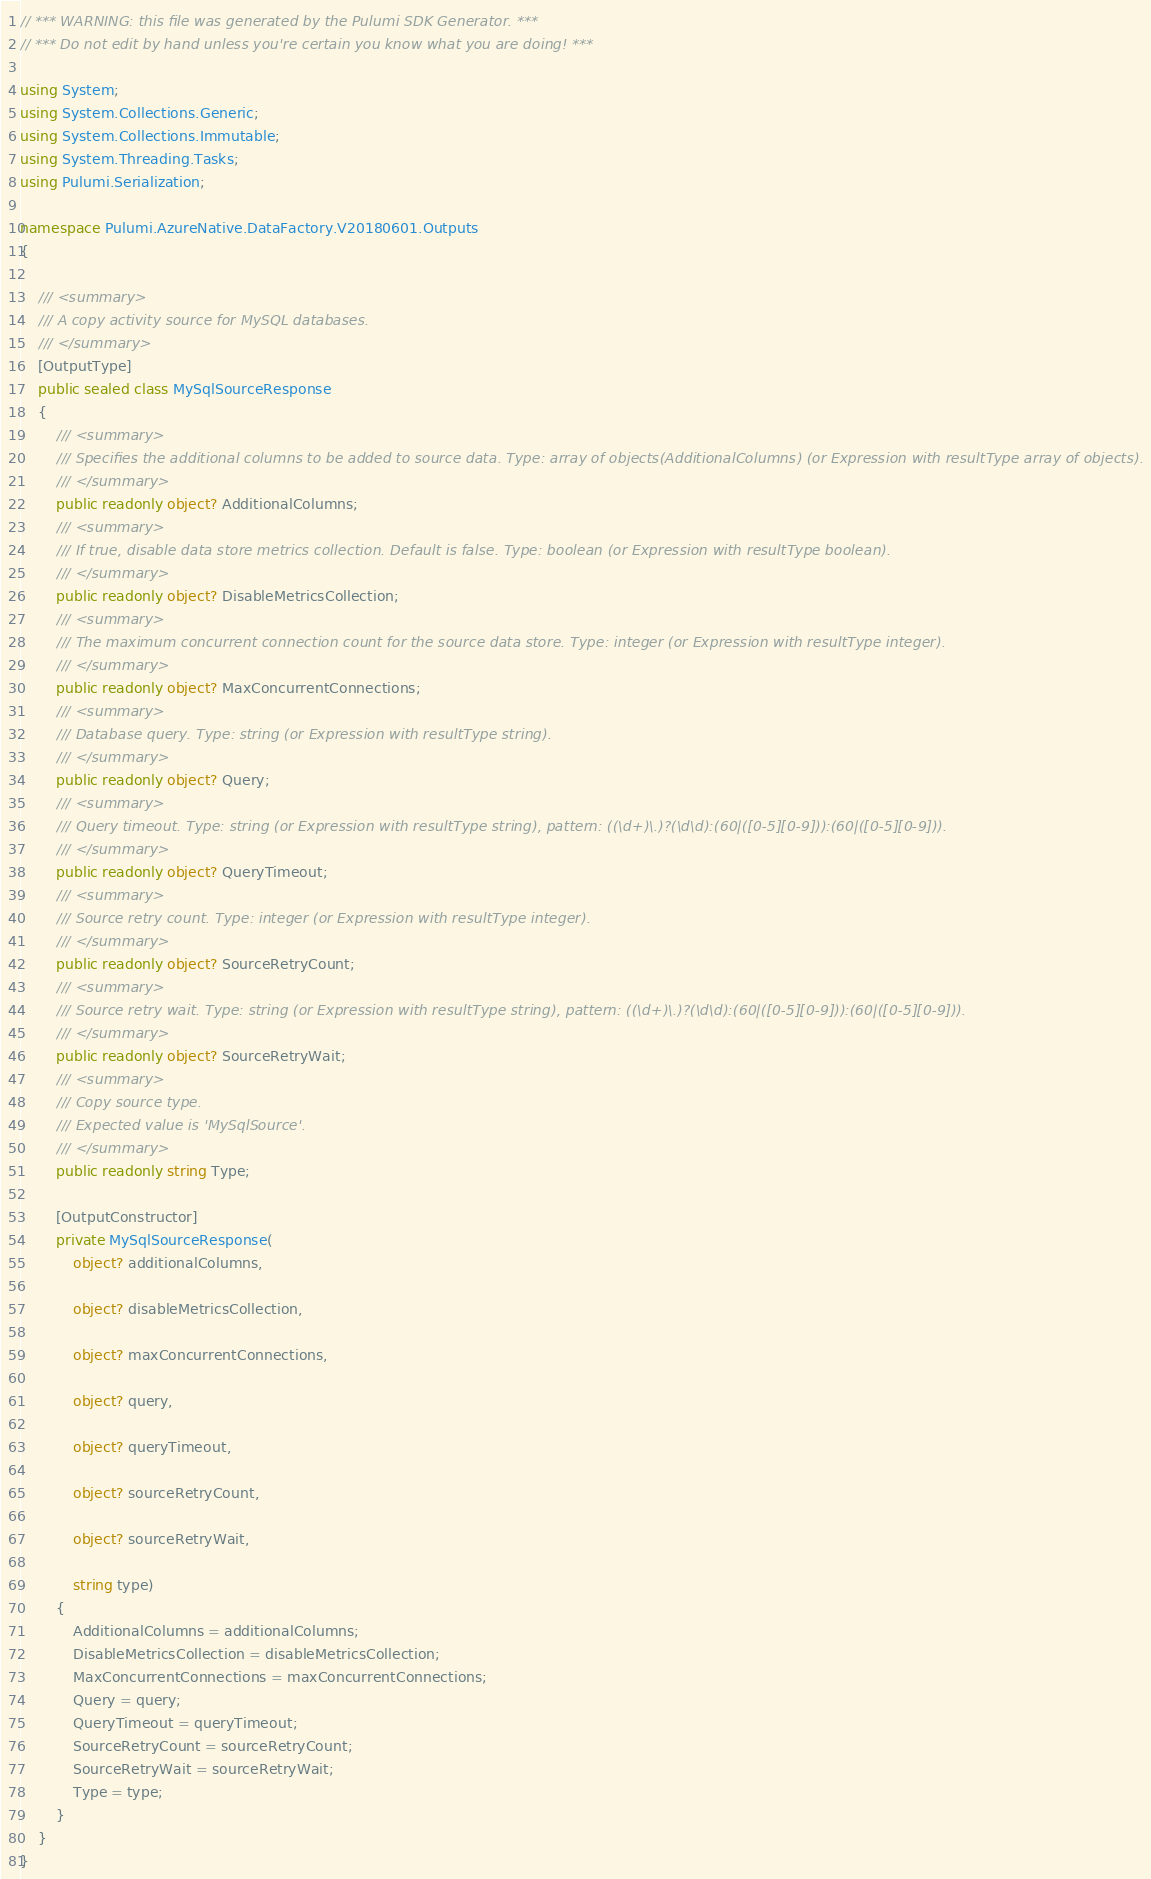<code> <loc_0><loc_0><loc_500><loc_500><_C#_>// *** WARNING: this file was generated by the Pulumi SDK Generator. ***
// *** Do not edit by hand unless you're certain you know what you are doing! ***

using System;
using System.Collections.Generic;
using System.Collections.Immutable;
using System.Threading.Tasks;
using Pulumi.Serialization;

namespace Pulumi.AzureNative.DataFactory.V20180601.Outputs
{

    /// <summary>
    /// A copy activity source for MySQL databases.
    /// </summary>
    [OutputType]
    public sealed class MySqlSourceResponse
    {
        /// <summary>
        /// Specifies the additional columns to be added to source data. Type: array of objects(AdditionalColumns) (or Expression with resultType array of objects).
        /// </summary>
        public readonly object? AdditionalColumns;
        /// <summary>
        /// If true, disable data store metrics collection. Default is false. Type: boolean (or Expression with resultType boolean).
        /// </summary>
        public readonly object? DisableMetricsCollection;
        /// <summary>
        /// The maximum concurrent connection count for the source data store. Type: integer (or Expression with resultType integer).
        /// </summary>
        public readonly object? MaxConcurrentConnections;
        /// <summary>
        /// Database query. Type: string (or Expression with resultType string).
        /// </summary>
        public readonly object? Query;
        /// <summary>
        /// Query timeout. Type: string (or Expression with resultType string), pattern: ((\d+)\.)?(\d\d):(60|([0-5][0-9])):(60|([0-5][0-9])).
        /// </summary>
        public readonly object? QueryTimeout;
        /// <summary>
        /// Source retry count. Type: integer (or Expression with resultType integer).
        /// </summary>
        public readonly object? SourceRetryCount;
        /// <summary>
        /// Source retry wait. Type: string (or Expression with resultType string), pattern: ((\d+)\.)?(\d\d):(60|([0-5][0-9])):(60|([0-5][0-9])).
        /// </summary>
        public readonly object? SourceRetryWait;
        /// <summary>
        /// Copy source type.
        /// Expected value is 'MySqlSource'.
        /// </summary>
        public readonly string Type;

        [OutputConstructor]
        private MySqlSourceResponse(
            object? additionalColumns,

            object? disableMetricsCollection,

            object? maxConcurrentConnections,

            object? query,

            object? queryTimeout,

            object? sourceRetryCount,

            object? sourceRetryWait,

            string type)
        {
            AdditionalColumns = additionalColumns;
            DisableMetricsCollection = disableMetricsCollection;
            MaxConcurrentConnections = maxConcurrentConnections;
            Query = query;
            QueryTimeout = queryTimeout;
            SourceRetryCount = sourceRetryCount;
            SourceRetryWait = sourceRetryWait;
            Type = type;
        }
    }
}
</code> 